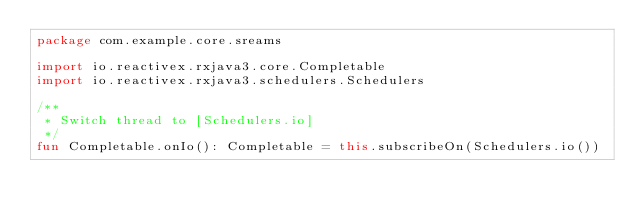<code> <loc_0><loc_0><loc_500><loc_500><_Kotlin_>package com.example.core.sreams

import io.reactivex.rxjava3.core.Completable
import io.reactivex.rxjava3.schedulers.Schedulers

/**
 * Switch thread to [Schedulers.io]
 */
fun Completable.onIo(): Completable = this.subscribeOn(Schedulers.io())</code> 